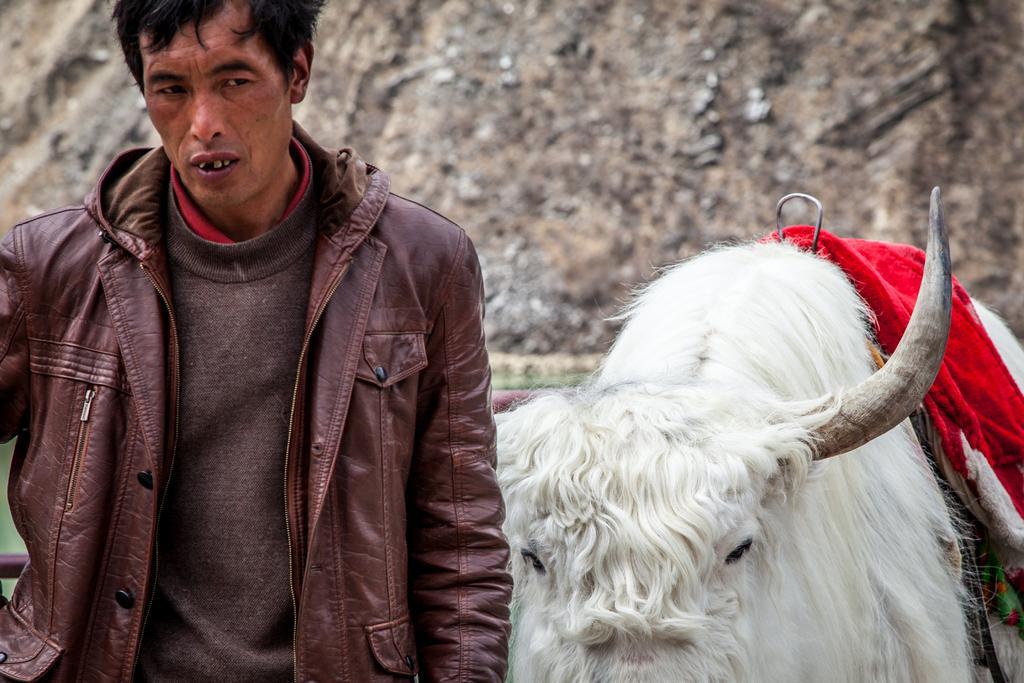Please provide a concise description of this image. In this image in the front there is a man and there is an animal and in the background it looks like a wall. In the center behind the man there is an object which is red in colour, which is visible. 